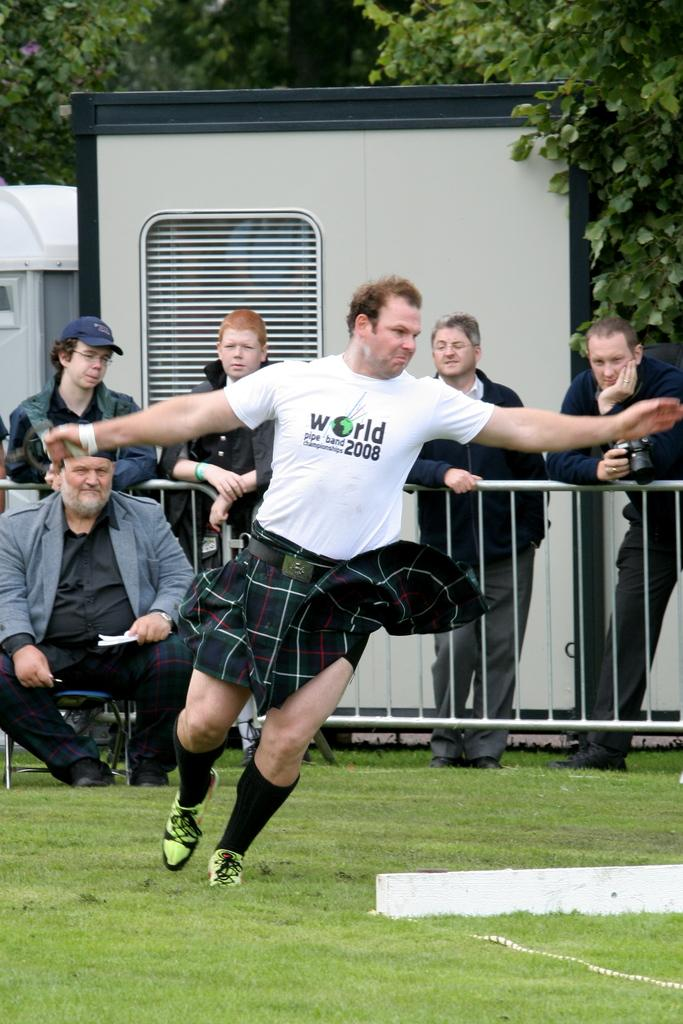Who or what can be seen in the image? There are people in the image. What type of natural environment is visible in the image? There is grass visible in the image. What are the barricades used for in the image? The barricades are present in the image, but their purpose is not specified. What can be seen in the distance in the image? There are trees and objects in the background of the image. How many cabbages are being carried by the ladybug in the image? There is no ladybug or cabbage present in the image. What direction are the people in the image walking? The provided facts do not specify the direction in which the people are walking. 